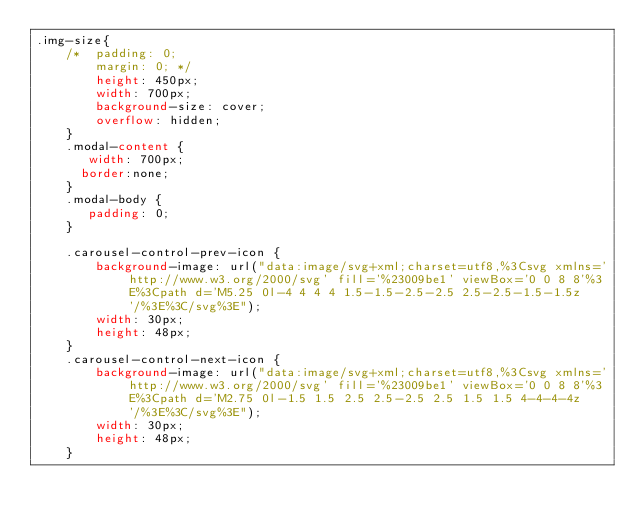Convert code to text. <code><loc_0><loc_0><loc_500><loc_500><_CSS_>.img-size{
    /* 	padding: 0;
        margin: 0; */
        height: 450px;
        width: 700px;
        background-size: cover;
        overflow: hidden;
    }
    .modal-content {
       width: 700px;
      border:none;
    }
    .modal-body {
       padding: 0;
    }
    
    .carousel-control-prev-icon {
        background-image: url("data:image/svg+xml;charset=utf8,%3Csvg xmlns='http://www.w3.org/2000/svg' fill='%23009be1' viewBox='0 0 8 8'%3E%3Cpath d='M5.25 0l-4 4 4 4 1.5-1.5-2.5-2.5 2.5-2.5-1.5-1.5z'/%3E%3C/svg%3E");
        width: 30px;
        height: 48px;
    }
    .carousel-control-next-icon {
        background-image: url("data:image/svg+xml;charset=utf8,%3Csvg xmlns='http://www.w3.org/2000/svg' fill='%23009be1' viewBox='0 0 8 8'%3E%3Cpath d='M2.75 0l-1.5 1.5 2.5 2.5-2.5 2.5 1.5 1.5 4-4-4-4z'/%3E%3C/svg%3E");
        width: 30px;
        height: 48px;
    }</code> 